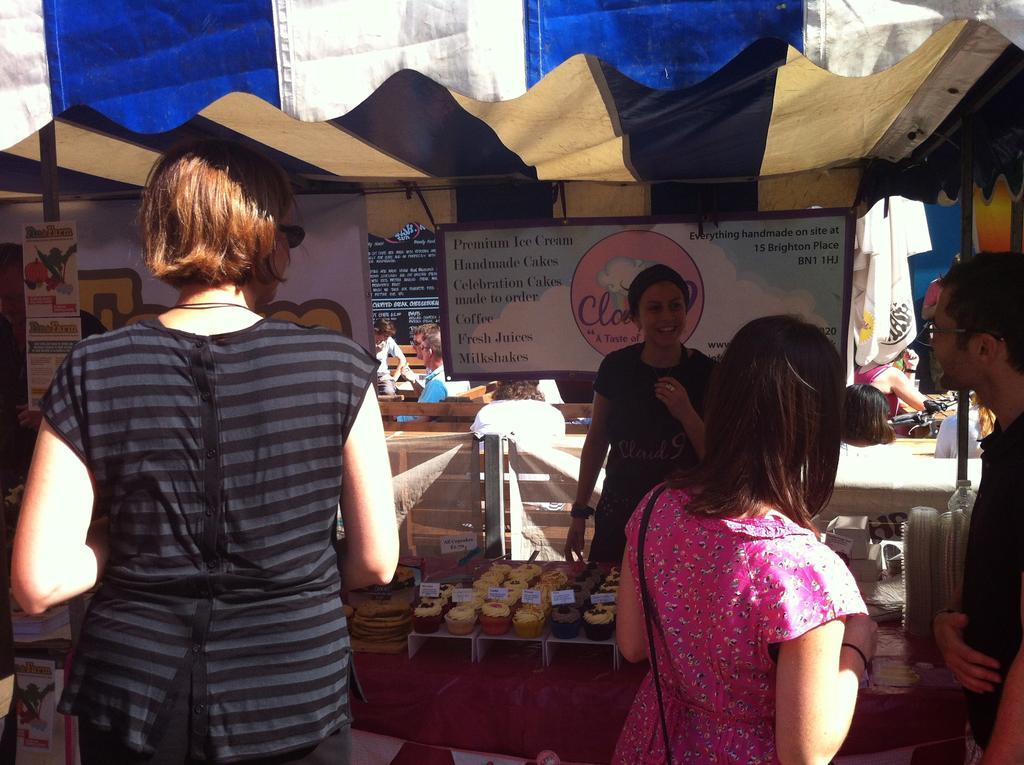Can you describe this image briefly? In this image I can see in the middle it looks like a store, at the bottom there are food items. On the left side a girl is standing and looking at her, at the top it is the tent. 